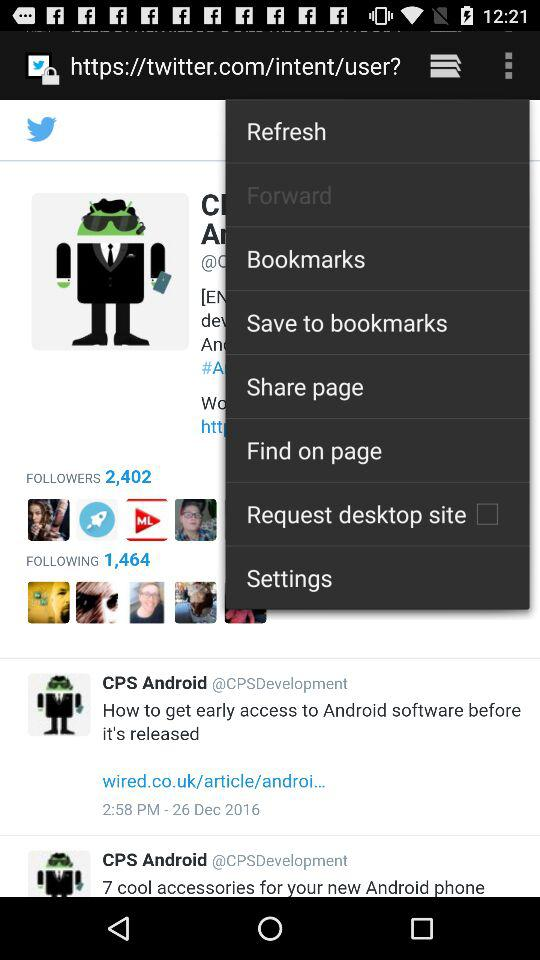How many followers are there? There are 2,402 followers. 